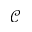Convert formula to latex. <formula><loc_0><loc_0><loc_500><loc_500>\mathcal { C }</formula> 